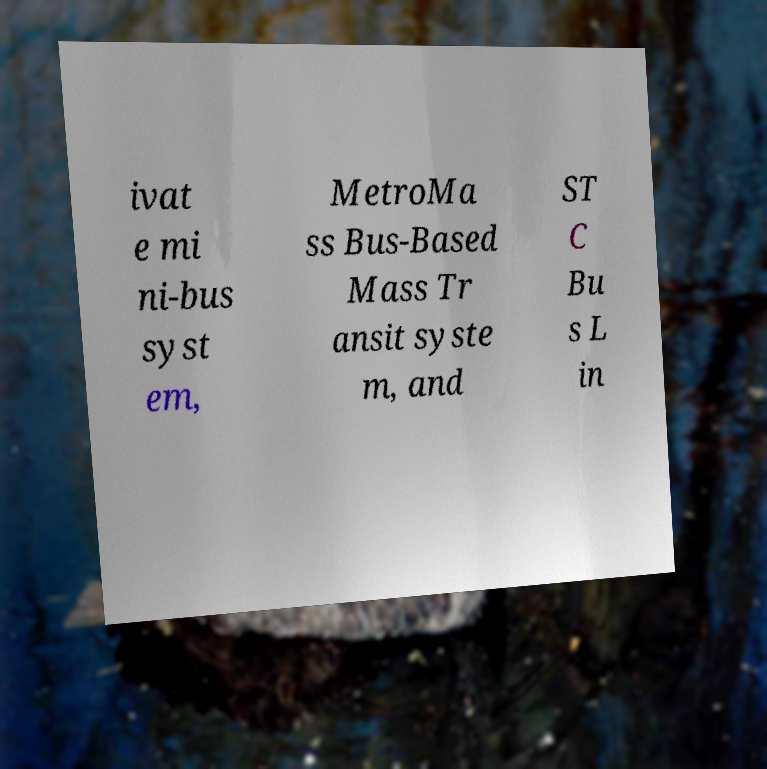I need the written content from this picture converted into text. Can you do that? ivat e mi ni-bus syst em, MetroMa ss Bus-Based Mass Tr ansit syste m, and ST C Bu s L in 